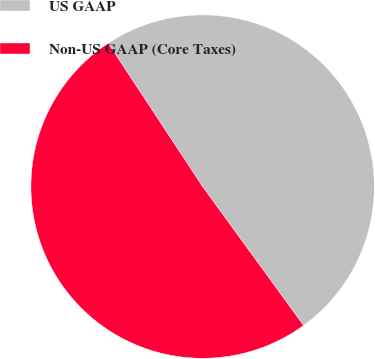Convert chart. <chart><loc_0><loc_0><loc_500><loc_500><pie_chart><fcel>US GAAP<fcel>Non-US GAAP (Core Taxes)<nl><fcel>49.26%<fcel>50.74%<nl></chart> 